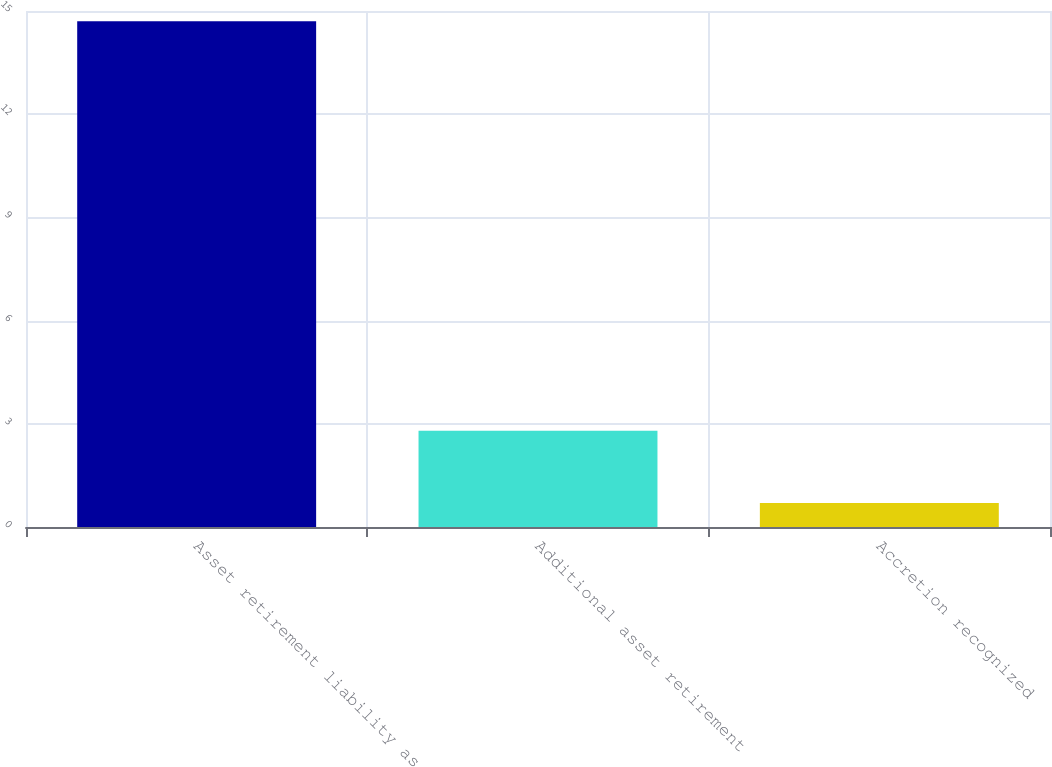<chart> <loc_0><loc_0><loc_500><loc_500><bar_chart><fcel>Asset retirement liability as<fcel>Additional asset retirement<fcel>Accretion recognized<nl><fcel>14.7<fcel>2.8<fcel>0.7<nl></chart> 